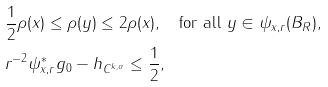<formula> <loc_0><loc_0><loc_500><loc_500>& \frac { 1 } { 2 } \rho ( x ) \leq \rho ( y ) \leq 2 \rho ( x ) , \quad \text {for all } y \in \psi _ { x , r } ( B _ { R } ) , \\ & \| r ^ { - 2 } \psi _ { x , r } ^ { * } g _ { 0 } - h \| _ { C ^ { k , \alpha } } \leq \frac { 1 } { 2 } ,</formula> 